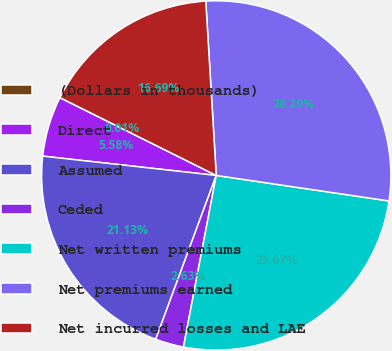<chart> <loc_0><loc_0><loc_500><loc_500><pie_chart><fcel>(Dollars in thousands)<fcel>Direct<fcel>Assumed<fcel>Ceded<fcel>Net written premiums<fcel>Net premiums earned<fcel>Net incurred losses and LAE<nl><fcel>0.01%<fcel>5.58%<fcel>21.13%<fcel>2.63%<fcel>25.67%<fcel>28.29%<fcel>16.69%<nl></chart> 